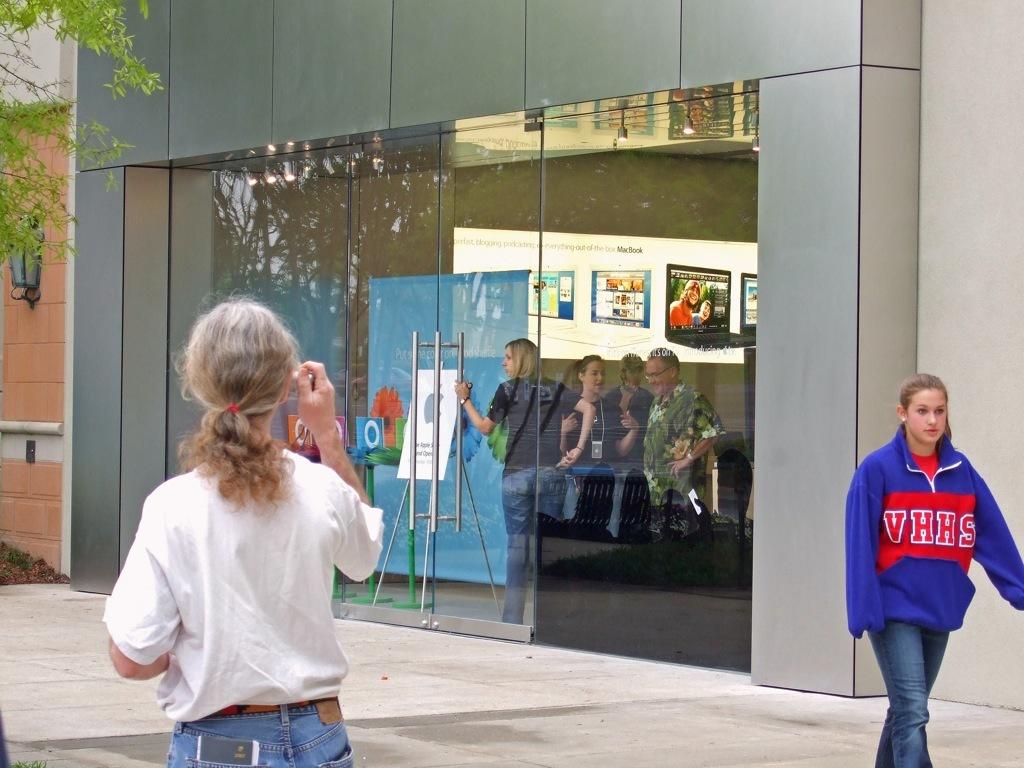What school is on the girl in blue's sweatshirt?
Your answer should be very brief. Vhhs. 